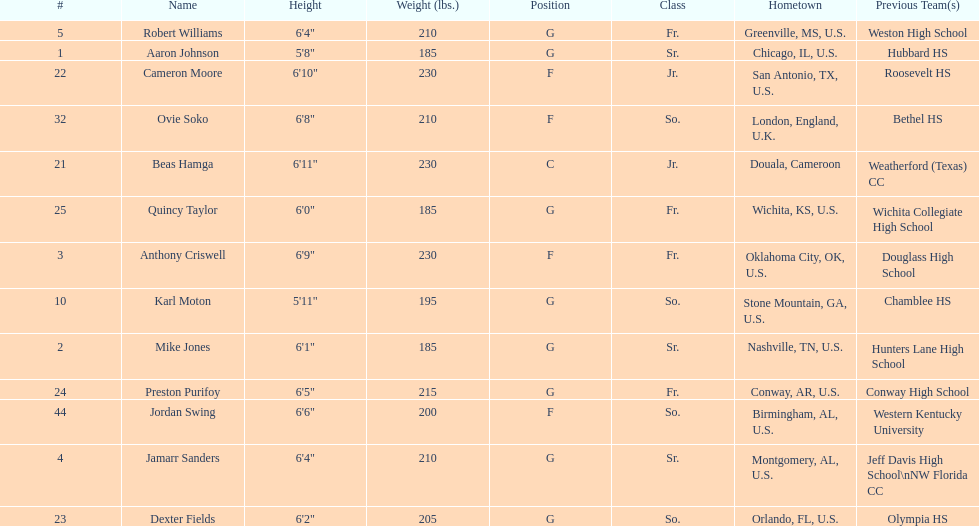How many forwards does the team have in total? 4. 